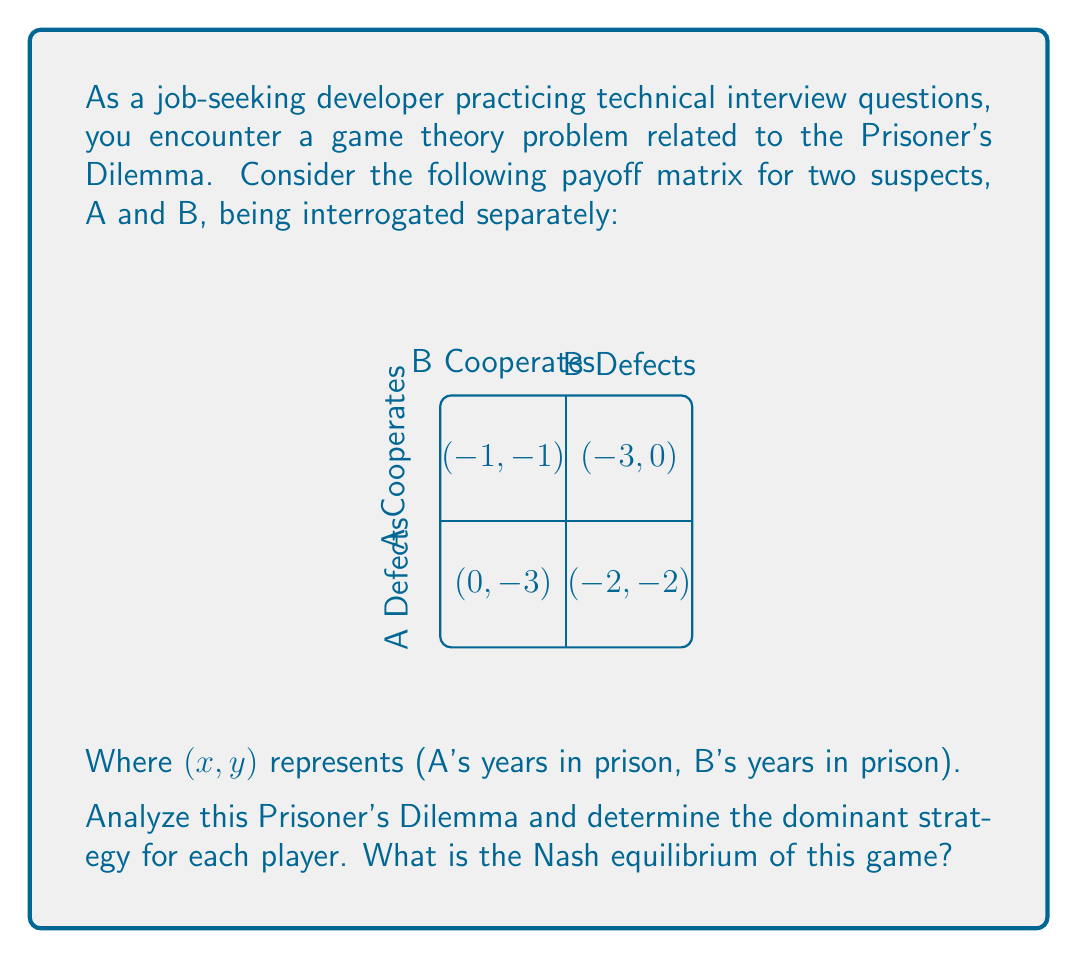Give your solution to this math problem. To solve this problem, we need to follow these steps:

1. Identify the dominant strategy for each player:
   - For player A:
     * If B cooperates: Defect (-0) < Cooperate (-1)
     * If B defects: Defect (-2) < Cooperate (-3)
     Defecting is always better for A, regardless of B's choice.
   
   - For player B:
     * If A cooperates: Defect (-0) < Cooperate (-1)
     * If A defects: Defect (-2) < Cooperate (-3)
     Defecting is always better for B, regardless of A's choice.

2. The dominant strategy for both players is to defect.

3. To find the Nash equilibrium, we need to identify a situation where neither player can unilaterally improve their outcome by changing their strategy.

   - If both players defect, the outcome is (-2, -2).
   - If A switches to cooperate while B defects, A's outcome worsens to -3.
   - If B switches to cooperate while A defects, B's outcome worsens to -3.

Therefore, (Defect, Defect) is the Nash equilibrium, as neither player can improve their situation by unilaterally changing their strategy.

This problem demonstrates the paradox of the Prisoner's Dilemma: although cooperation would lead to a better outcome for both players (-1, -1), the dominant strategy and Nash equilibrium is mutual defection, resulting in a worse outcome for both (-2, -2).
Answer: Dominant strategy: Defect for both players. Nash equilibrium: (Defect, Defect) 